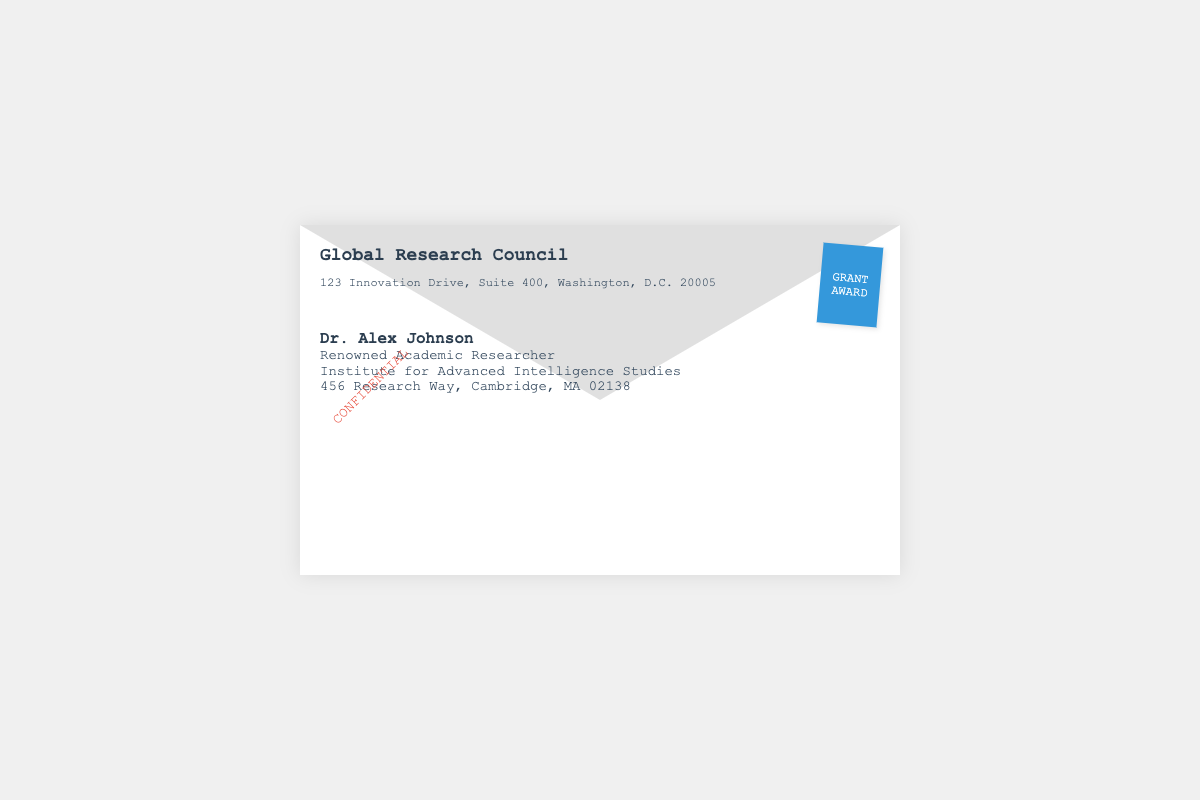what is the name of the organization sending the grant notification? The name of the organization is stated in the logo section of the document.
Answer: Global Research Council who is the recipient of the grant notification? The recipient's name is provided under the recipient section of the document.
Answer: Dr. Alex Johnson what is the address of the recipient? The recipient's address is found in the recipient details section of the document.
Answer: 456 Research Way, Cambridge, MA 02138 what is the primary role of the recipient? The recipient’s title is given in the recipient details section.
Answer: Renowned Academic Researcher where is the organization located? The organization's address is listed at the top of the document.
Answer: 123 Innovation Drive, Suite 400, Washington, D.C. 20005 what color is the stamp on the envelope? The color of the stamp is visually evident in the envelope design.
Answer: Blue what does the confidential label indicate? The confidential label suggests the sensitivity of the information regarding the grant.
Answer: Sensitive information is there a specific term mentioned in the document for the grant approval? This document type may include specific grant terms which should be identified within the content.
Answer: Confidential what is the significance of the logo? The logo signifies the authority and source of the grant notification.
Answer: Grant provider identification 